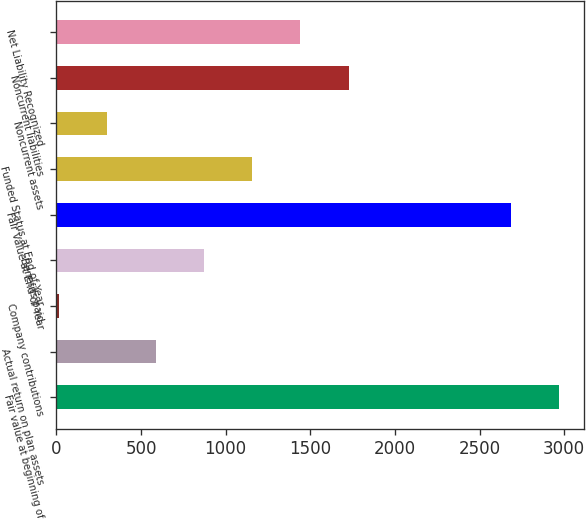Convert chart. <chart><loc_0><loc_0><loc_500><loc_500><bar_chart><fcel>Fair value at beginning of<fcel>Actual return on plan assets<fcel>Company contributions<fcel>Benefits paid<fcel>Fair Value at End of Year<fcel>Funded Status at End of Year<fcel>Noncurrent assets<fcel>Noncurrent liabilities<fcel>Net Liability Recognized<nl><fcel>2970.36<fcel>585.52<fcel>14.6<fcel>870.98<fcel>2684.9<fcel>1156.44<fcel>300.06<fcel>1727.36<fcel>1441.9<nl></chart> 